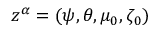Convert formula to latex. <formula><loc_0><loc_0><loc_500><loc_500>z ^ { \alpha } = ( \psi , \theta , \mu _ { 0 } , \zeta _ { 0 } )</formula> 